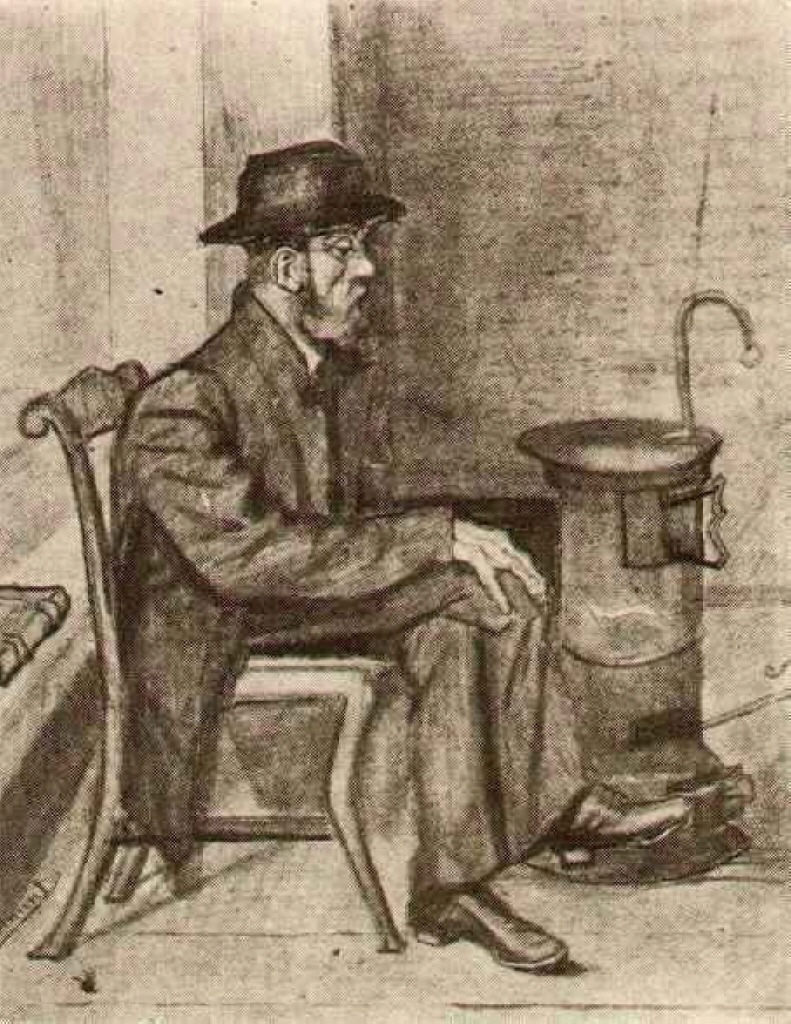What might be the historical context of the scene depicted in this image? The image likely reflects a scene from the late 19th or early 20th century, as suggested by the man's attire and the design of the stove. During this period, many people dressed in heavy, dark clothing to stay warm during the colder months, and stoves like the one depicted were commonly used for heating. The image may portray the daily life of a common man at the time, perhaps reflecting on his day or pondering his future. The earthy tones and the man's contemplative pose add to the nostalgic and reflective mood of the piece. 